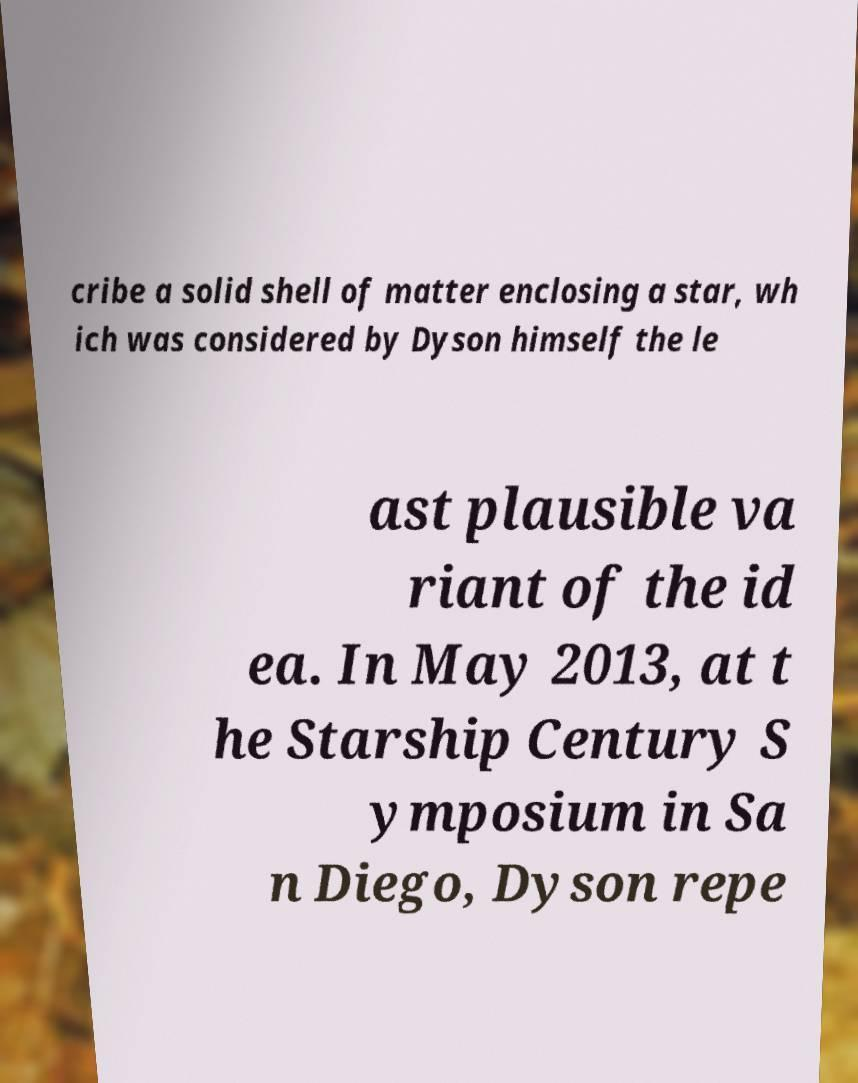Could you extract and type out the text from this image? cribe a solid shell of matter enclosing a star, wh ich was considered by Dyson himself the le ast plausible va riant of the id ea. In May 2013, at t he Starship Century S ymposium in Sa n Diego, Dyson repe 